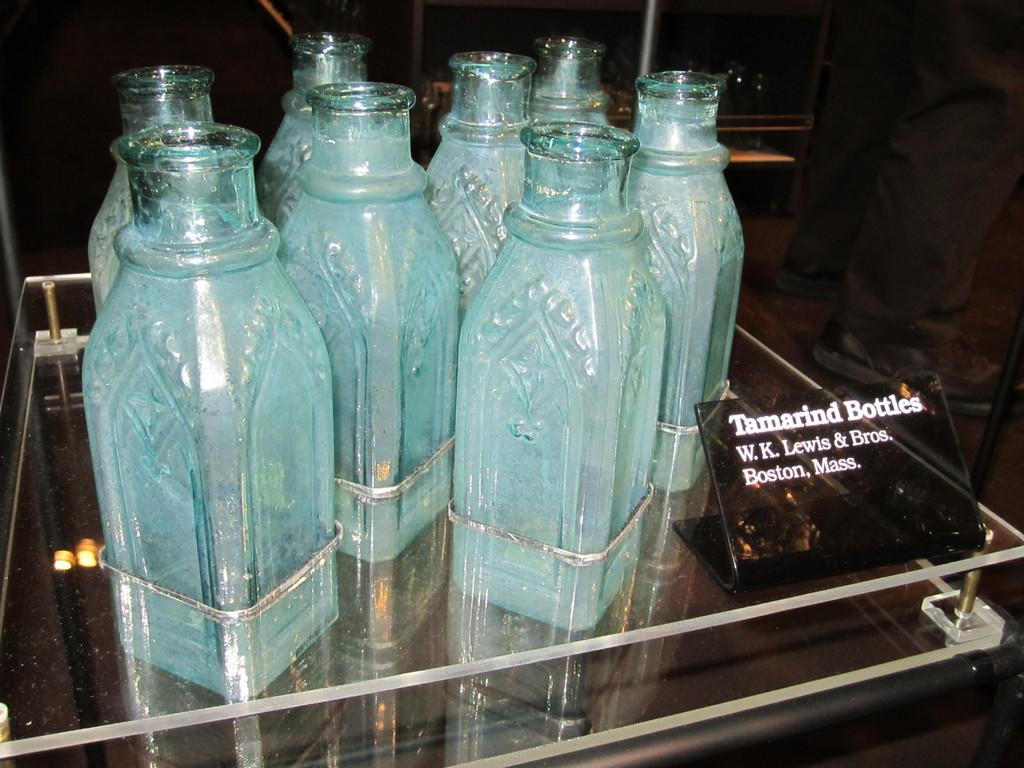<image>
Share a concise interpretation of the image provided. A group of bottles with a sign labelling them as "Tamarind bottles". 